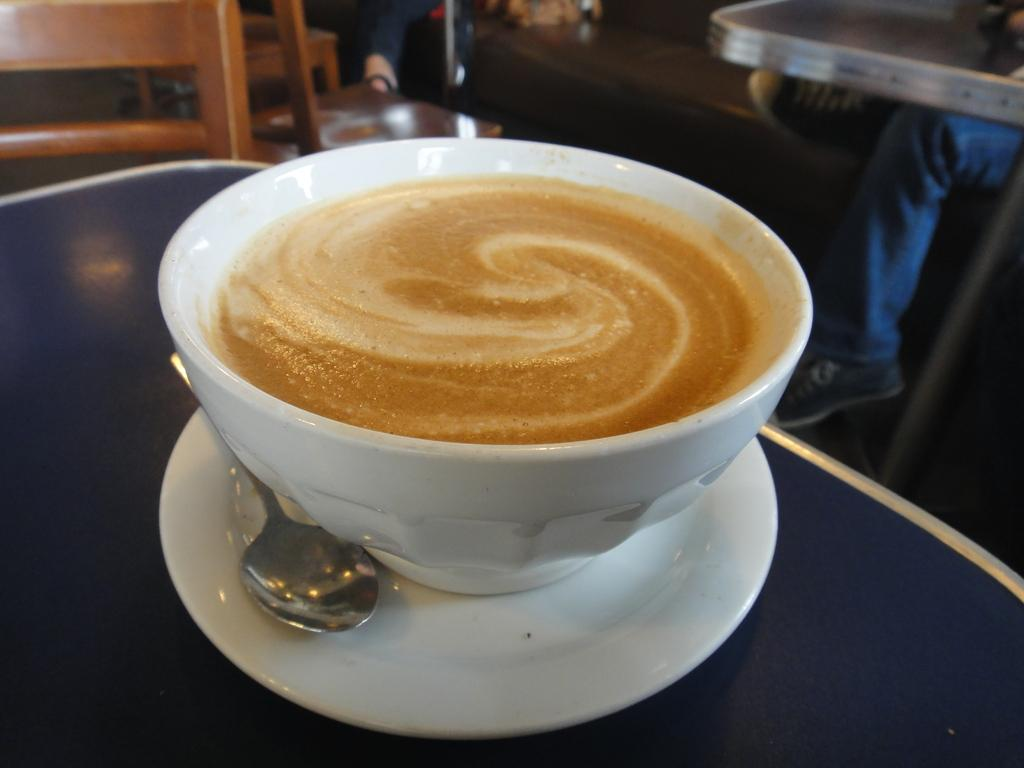What is inside the cup that is visible in the image? The cup is filled with coffee. What utensil is associated with the cup? There is a spoon in the image, and it is associated with the cup. What is the saucer used for in the image? The saucer is used to hold the cup and is kept on the table. Where are the cup, spoon, and saucer located in the image? They are all on a table. What type of veil is draped over the cup in the image? There is no veil present in the image; it only features a cup filled with coffee, a spoon, and a saucer on a table. 